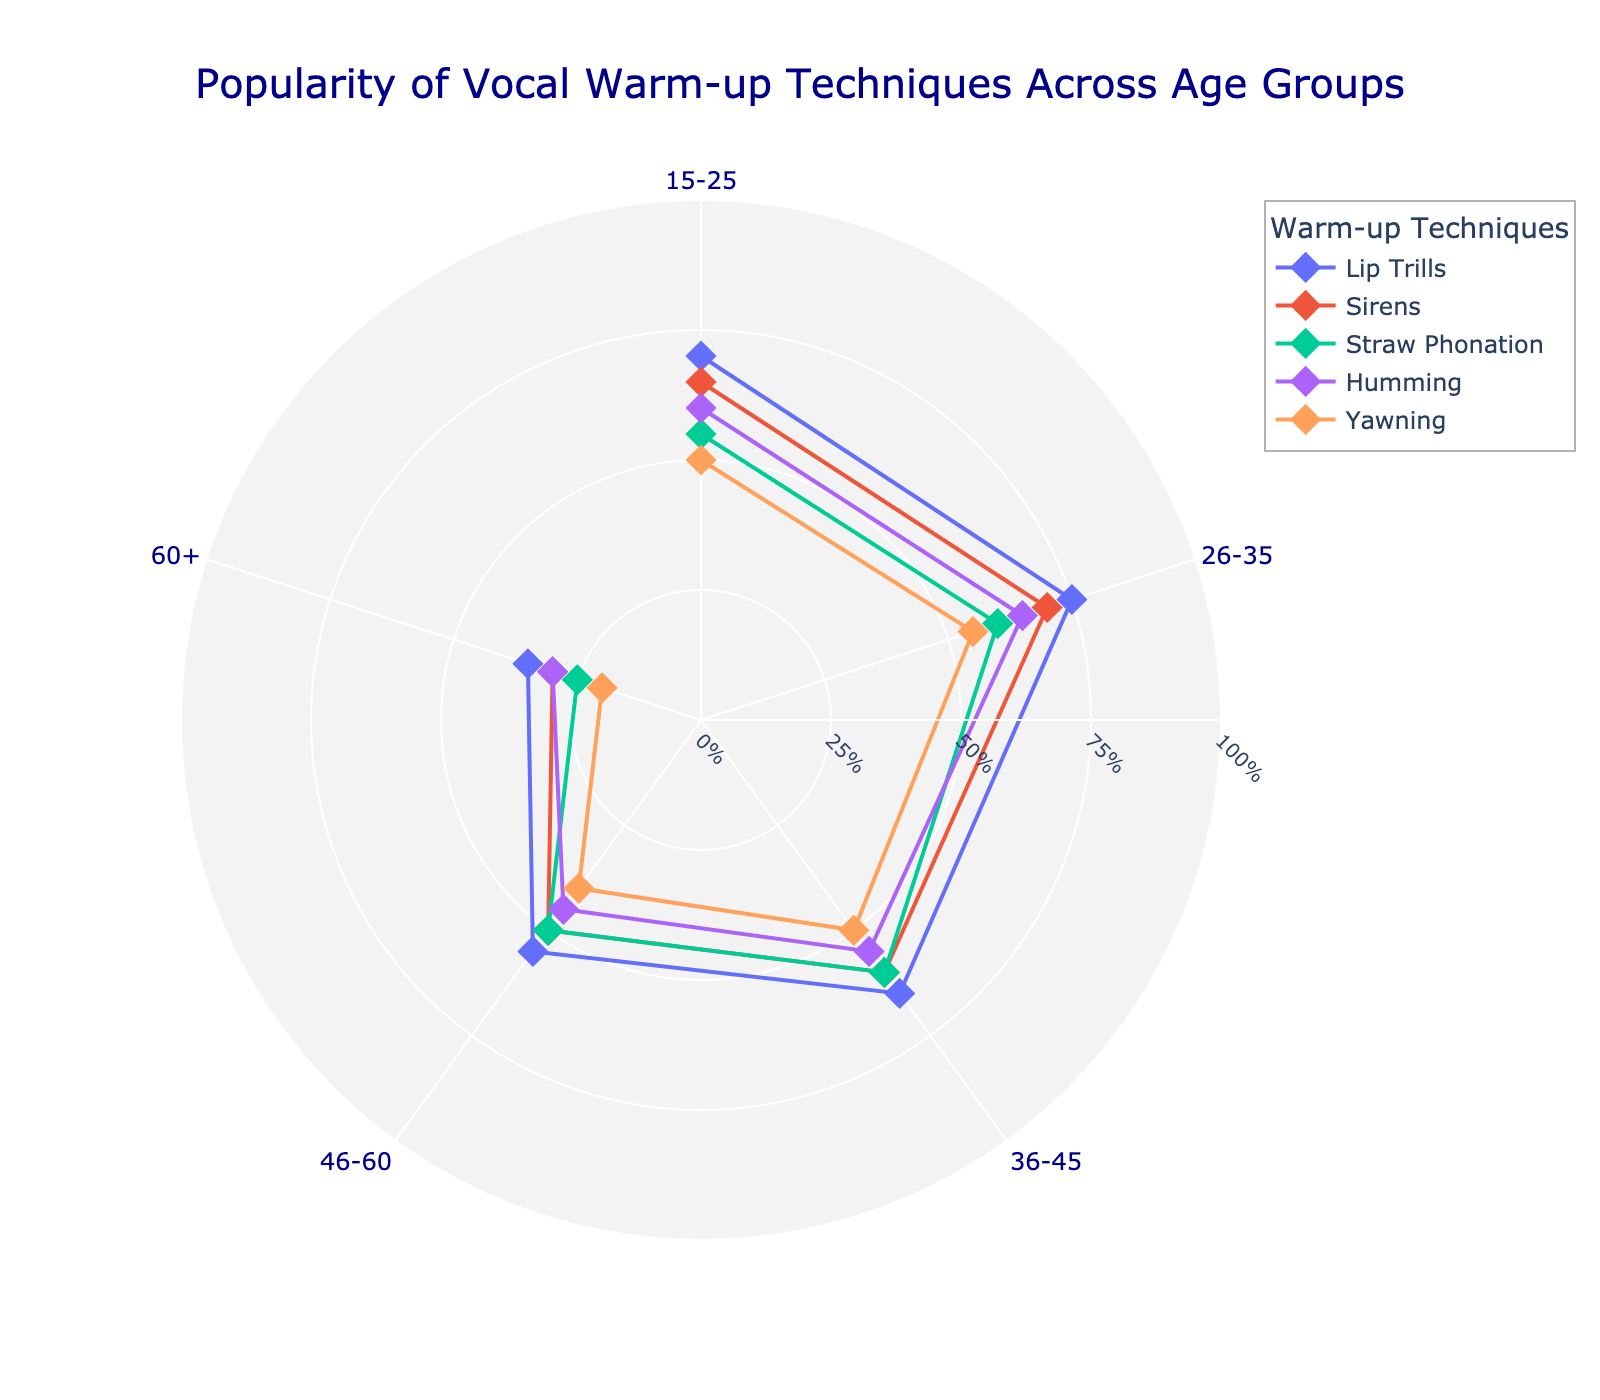What is the title of the figure? The title of the plot is indicated at the top of the figure. It is "Popularity of Vocal Warm-up Techniques Across Age Groups".
Answer: Popularity of Vocal Warm-up Techniques Across Age Groups What is the popularity percentage of Lip Trills in the age group 26-35? Look at the data point marked by "Lip Trills" in the 26-35 age group sector (72 degrees angle) and read its radius value.
Answer: 75% Which vocal warm-up technique is the least popular among the 60+ age group? Look at the 60+ age group sector (288 degrees angle), find the data points representing all vocal techniques, and identify the one with the smallest radius.
Answer: Yawning Among the age group 15-25, which technique is more popular: Sirens or Humming? Compare the radius of the data points for "Sirens" and "Humming" within the 15-25 age group sector (0 degrees angle).
Answer: Sirens How many different age groups are represented in the plot? Count the distinct segments along the angular axis representing different age ranges.
Answer: 5 What is the difference in popularity between Straw Phonation for the age groups 26-35 and 46-60? Subtract the popularity percentage of Straw Phonation in the 46-60 age group (50%) from that in the 26-35 age group (60%).
Answer: 10% What is the average popularity of Yawning across all age groups? Add the popularity percentages of Yawning for all age groups (50%, 55%, 50%, 40%, 20%) and divide by the number of groups (5).
Answer: 43% Which vocal warm-up technique has the highest overall popularity in the 36-45 age group? Among the data points in the 36-45 age group sector (144 degrees angle), find the one with the largest radius.
Answer: Lip Trills Is there any age group where Sirens is not the second most popular technique? Compare the popularity percentages of Sirens with other techniques across all age groups and check if there's any deviation from being second in rank.
Answer: Yes (in the 60+ age group, Sirens is the third most popular) 